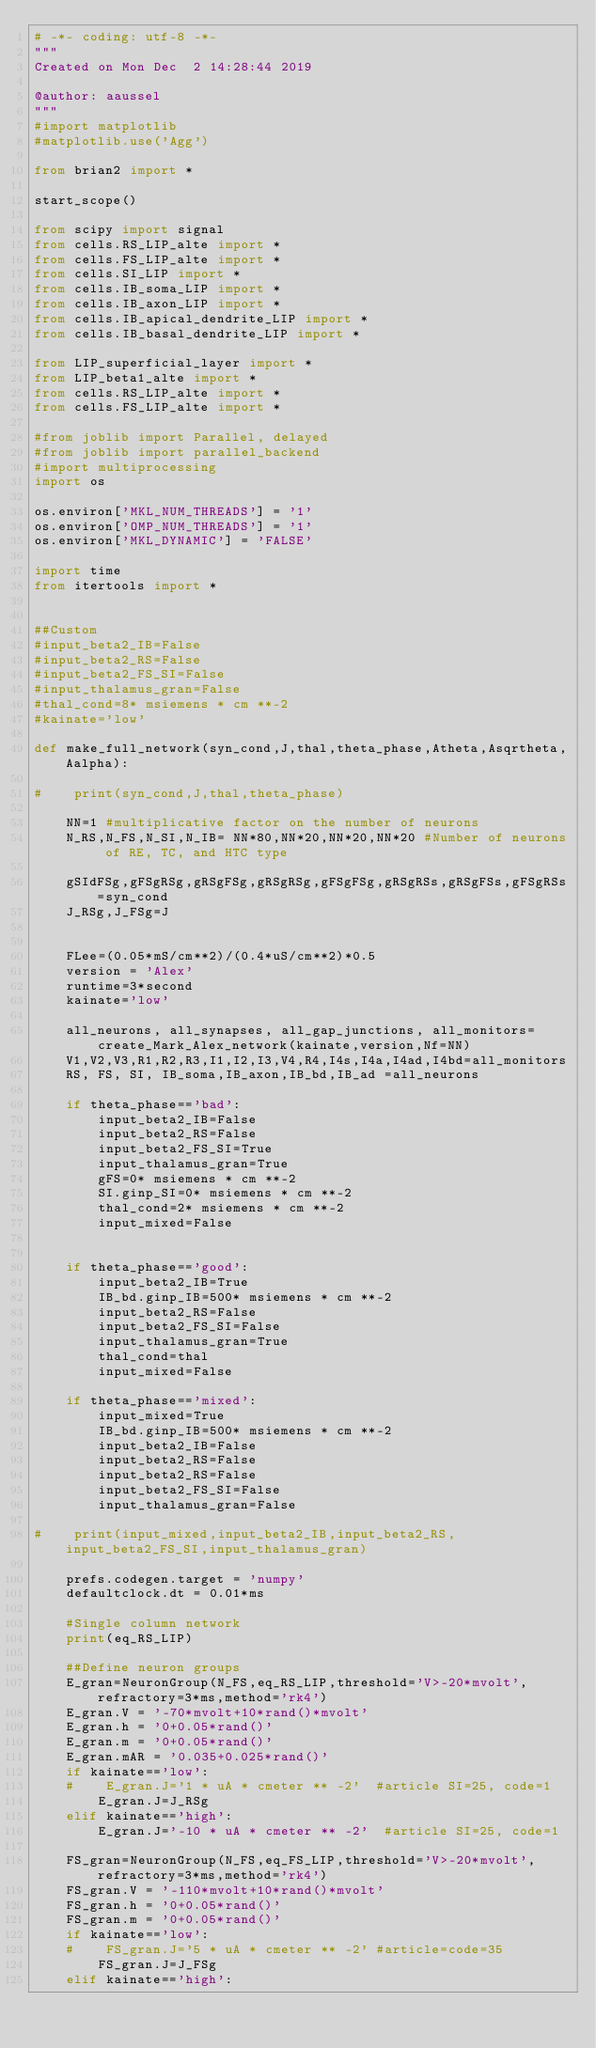Convert code to text. <code><loc_0><loc_0><loc_500><loc_500><_Python_># -*- coding: utf-8 -*-
"""
Created on Mon Dec  2 14:28:44 2019

@author: aaussel
"""
#import matplotlib
#matplotlib.use('Agg')

from brian2 import *

start_scope()

from scipy import signal
from cells.RS_LIP_alte import *
from cells.FS_LIP_alte import *
from cells.SI_LIP import *
from cells.IB_soma_LIP import *
from cells.IB_axon_LIP import *
from cells.IB_apical_dendrite_LIP import *
from cells.IB_basal_dendrite_LIP import *

from LIP_superficial_layer import *
from LIP_beta1_alte import *
from cells.RS_LIP_alte import *
from cells.FS_LIP_alte import *

#from joblib import Parallel, delayed
#from joblib import parallel_backend
#import multiprocessing
import os

os.environ['MKL_NUM_THREADS'] = '1'
os.environ['OMP_NUM_THREADS'] = '1'
os.environ['MKL_DYNAMIC'] = 'FALSE'

import time
from itertools import *

    
##Custom
#input_beta2_IB=False
#input_beta2_RS=False
#input_beta2_FS_SI=False
#input_thalamus_gran=False
#thal_cond=8* msiemens * cm **-2
#kainate='low'
    
def make_full_network(syn_cond,J,thal,theta_phase,Atheta,Asqrtheta,Aalpha):
    
#    print(syn_cond,J,thal,theta_phase)    
    
    NN=1 #multiplicative factor on the number of neurons
    N_RS,N_FS,N_SI,N_IB= NN*80,NN*20,NN*20,NN*20 #Number of neurons of RE, TC, and HTC type
    
    gSIdFSg,gFSgRSg,gRSgFSg,gRSgRSg,gFSgFSg,gRSgRSs,gRSgFSs,gFSgRSs=syn_cond
    J_RSg,J_FSg=J
    
 
    FLee=(0.05*mS/cm**2)/(0.4*uS/cm**2)*0.5
    version = 'Alex'
    runtime=3*second
    kainate='low'
    
    all_neurons, all_synapses, all_gap_junctions, all_monitors=create_Mark_Alex_network(kainate,version,Nf=NN)
    V1,V2,V3,R1,R2,R3,I1,I2,I3,V4,R4,I4s,I4a,I4ad,I4bd=all_monitors
    RS, FS, SI, IB_soma,IB_axon,IB_bd,IB_ad =all_neurons
   
    if theta_phase=='bad':
        input_beta2_IB=False
        input_beta2_RS=False
        input_beta2_FS_SI=True
        input_thalamus_gran=True
        gFS=0* msiemens * cm **-2
        SI.ginp_SI=0* msiemens * cm **-2
        thal_cond=2* msiemens * cm **-2
        input_mixed=False
        
        
    if theta_phase=='good':
        input_beta2_IB=True
        IB_bd.ginp_IB=500* msiemens * cm **-2
        input_beta2_RS=False
        input_beta2_FS_SI=False
        input_thalamus_gran=True
        thal_cond=thal
        input_mixed=False
        
    if theta_phase=='mixed':
        input_mixed=True
        IB_bd.ginp_IB=500* msiemens * cm **-2
        input_beta2_IB=False
        input_beta2_RS=False
        input_beta2_RS=False
        input_beta2_FS_SI=False
        input_thalamus_gran=False
        
#    print(input_mixed,input_beta2_IB,input_beta2_RS,input_beta2_FS_SI,input_thalamus_gran)
        
    prefs.codegen.target = 'numpy'
    defaultclock.dt = 0.01*ms
    
    #Single column network
    print(eq_RS_LIP)
    
    ##Define neuron groups
    E_gran=NeuronGroup(N_FS,eq_RS_LIP,threshold='V>-20*mvolt',refractory=3*ms,method='rk4')
    E_gran.V = '-70*mvolt+10*rand()*mvolt'
    E_gran.h = '0+0.05*rand()'
    E_gran.m = '0+0.05*rand()'
    E_gran.mAR = '0.035+0.025*rand()'
    if kainate=='low':
    #    E_gran.J='1 * uA * cmeter ** -2'  #article SI=25, code=1
        E_gran.J=J_RSg
    elif kainate=='high':
        E_gran.J='-10 * uA * cmeter ** -2'  #article SI=25, code=1
        
    FS_gran=NeuronGroup(N_FS,eq_FS_LIP,threshold='V>-20*mvolt',refractory=3*ms,method='rk4')
    FS_gran.V = '-110*mvolt+10*rand()*mvolt'
    FS_gran.h = '0+0.05*rand()'
    FS_gran.m = '0+0.05*rand()'
    if kainate=='low':
    #    FS_gran.J='5 * uA * cmeter ** -2' #article=code=35
        FS_gran.J=J_FSg
    elif kainate=='high':</code> 